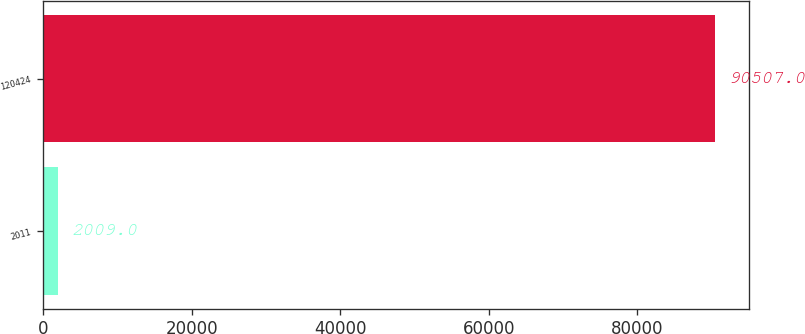<chart> <loc_0><loc_0><loc_500><loc_500><bar_chart><fcel>2011<fcel>120424<nl><fcel>2009<fcel>90507<nl></chart> 